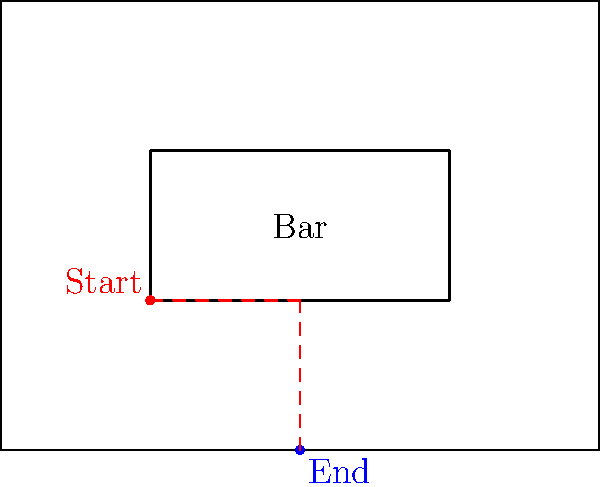On your bar's floor plan, a bartender needs to move from their current position at the corner of the bar (marked in red) to a new workstation (marked in blue). Describe the sequence of transformations needed to move the bartender efficiently, using only translations and rotations. Let's break down the movement into steps:

1. First, we need to move the bartender from the corner of the bar to the center of the bar's edge. This is a horizontal translation to the right.

   Translation: $T_1 = (1, 0)$

2. Next, we need to rotate the bartender 90 degrees clockwise to face the new workstation. The center of rotation is the current position after the first translation.

   Rotation: $R_{90°}$ (clockwise)

3. Finally, we need to translate the bartender down to the new workstation.

   Translation: $T_2 = (0, -1)$

The complete sequence of transformations is:

1. Translate right: $T_1 = (1, 0)$
2. Rotate 90° clockwise: $R_{90°}$
3. Translate down: $T_2 = (0, -1)$

This sequence efficiently moves the bartender from the starting position to the ending position using only translations and rotations.
Answer: $T_1 \circ R_{90°} \circ T_2$ 